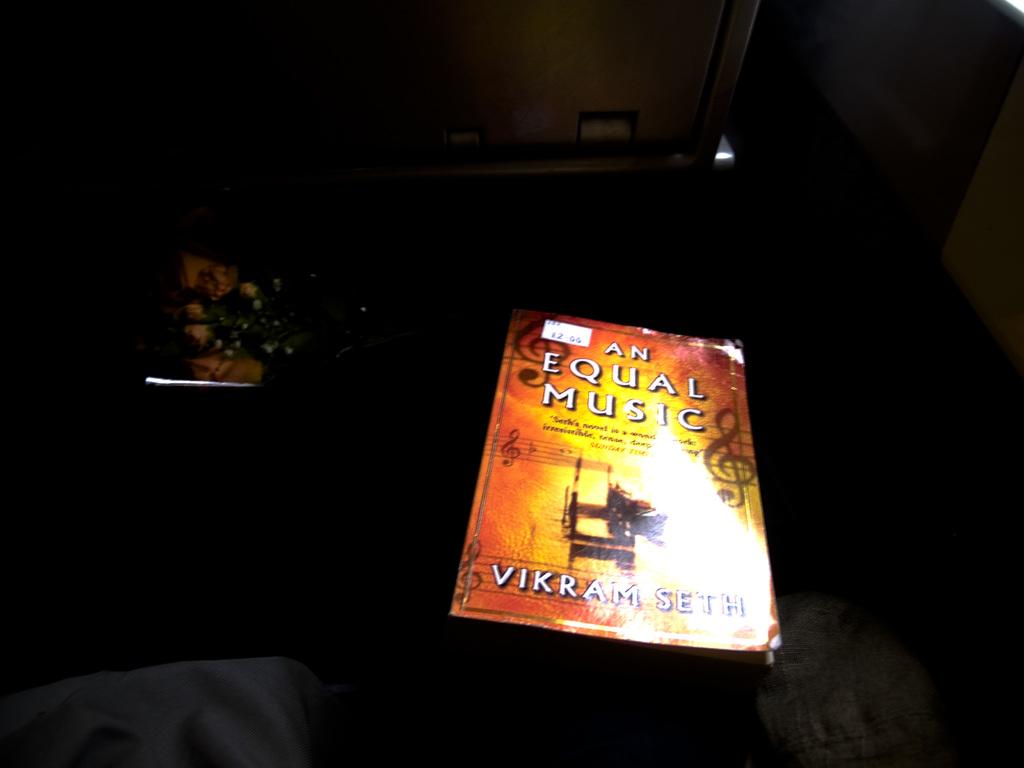Who is the author of an equal music?
Offer a terse response. Vikram seth. What is the name of the book?
Make the answer very short. An equal music. 